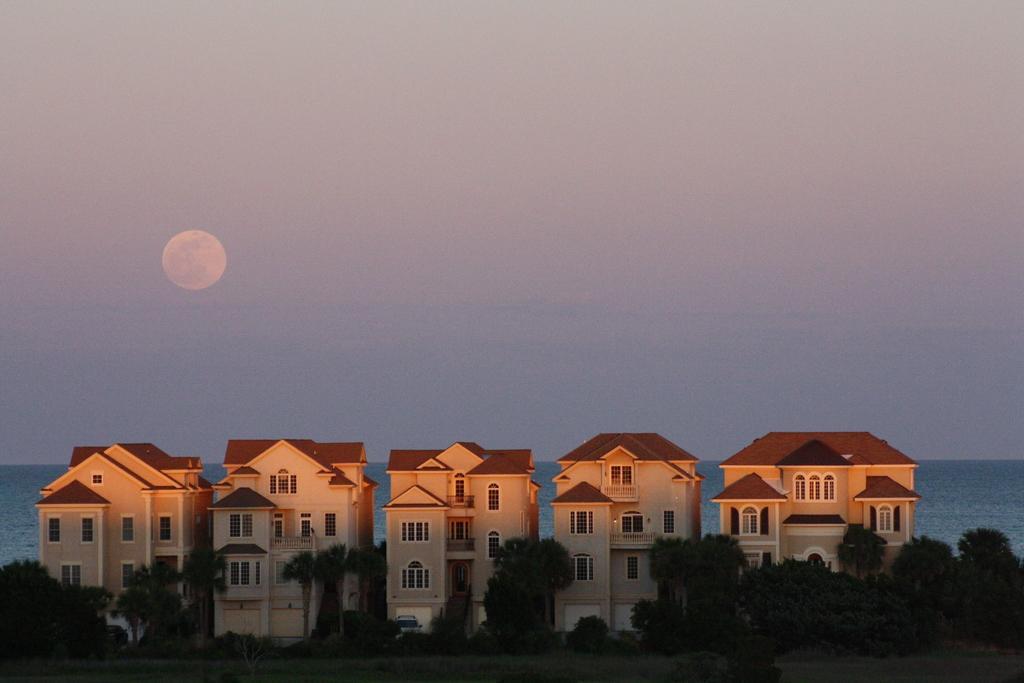Please provide a concise description of this image. There are five buildings with windows and doors. This looks like a car, which is parked in front of the building. These are the trees and plants. I think here is the water flowing. This is the moon in the sky. 